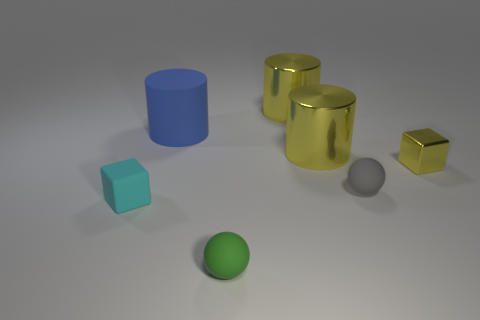There is a cube right of the tiny gray rubber thing; is its size the same as the cyan matte cube left of the green rubber thing?
Provide a short and direct response. Yes. What number of objects are either yellow metallic objects on the left side of the shiny block or tiny things that are to the right of the cyan matte object?
Ensure brevity in your answer.  5. Does the large object that is behind the blue cylinder have the same color as the object that is to the right of the tiny gray sphere?
Ensure brevity in your answer.  Yes. How many rubber things are yellow things or big blue objects?
Give a very brief answer. 1. What is the shape of the big object to the left of the ball that is in front of the small gray ball?
Your response must be concise. Cylinder. Does the small cube in front of the yellow metallic cube have the same material as the small cube that is right of the green sphere?
Your answer should be very brief. No. What number of tiny things are in front of the small block that is right of the big blue matte cylinder?
Your answer should be very brief. 3. There is a large yellow shiny thing that is behind the big blue matte cylinder; is its shape the same as the blue thing that is behind the small green matte object?
Your answer should be very brief. Yes. What size is the rubber thing that is both to the left of the gray ball and behind the tiny cyan matte thing?
Your response must be concise. Large. There is another matte object that is the same shape as the gray thing; what color is it?
Give a very brief answer. Green. 